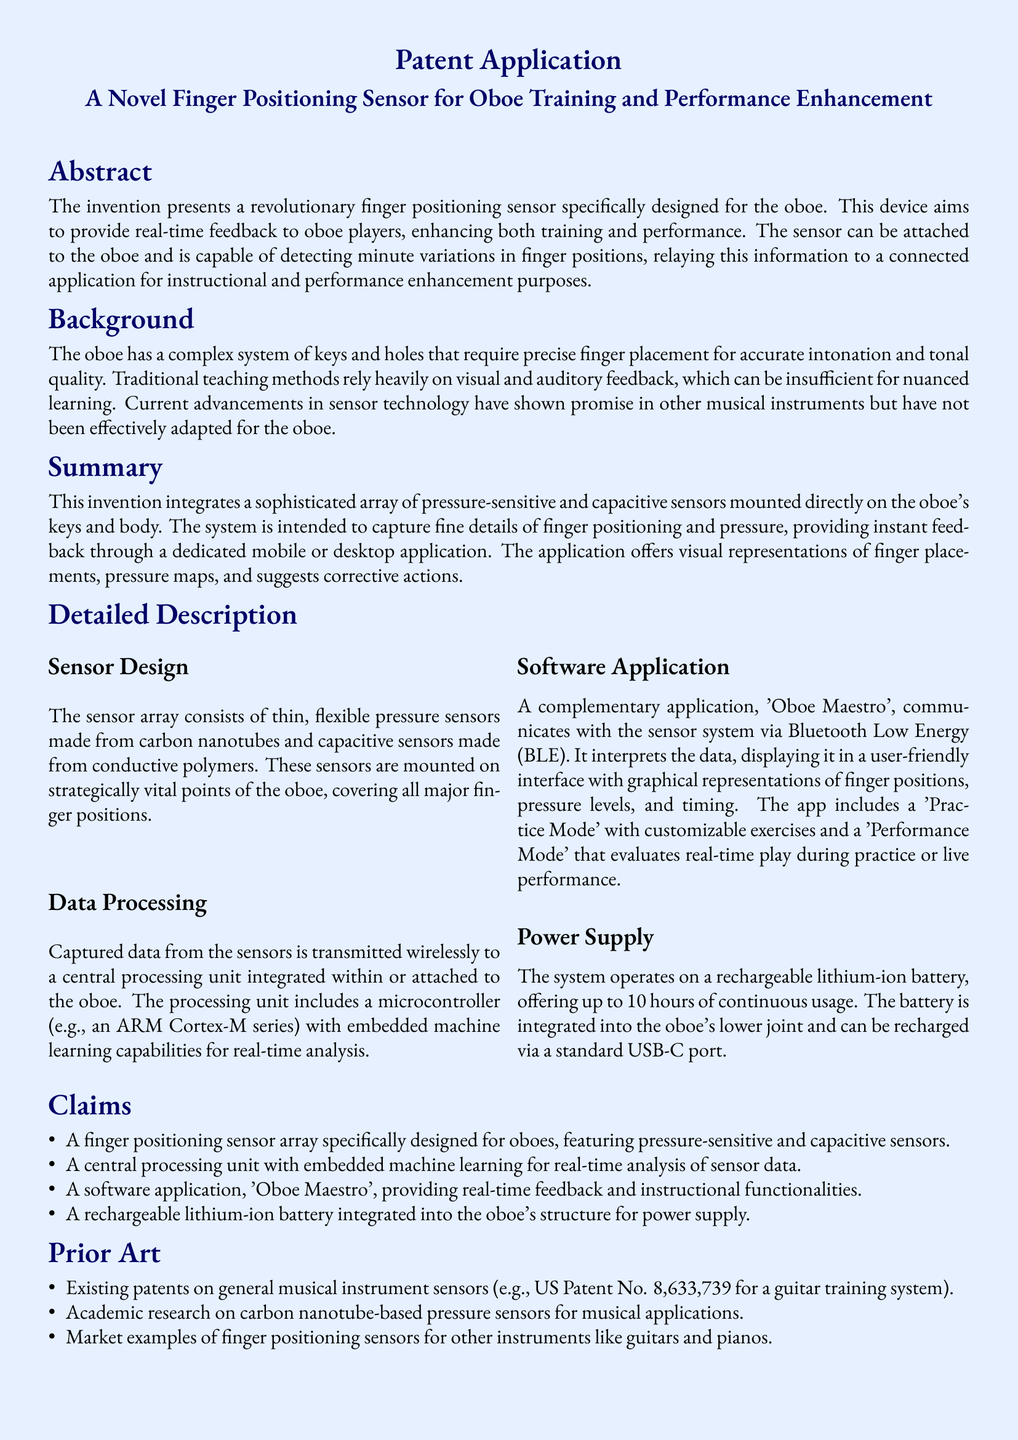What is the name of the novel sensor? The document specifies the invention as "A Novel Finger Positioning Sensor for Oboe Training and Performance Enhancement."
Answer: A Novel Finger Positioning Sensor for Oboe Training and Performance Enhancement What type of sensors does the device use? The document mentions "pressure-sensitive and capacitive sensors" as the types used in the device.
Answer: Pressure-sensitive and capacitive sensors What is the name of the complementary application? The software application that accompanies the sensor system is referred to as 'Oboe Maestro' in the document.
Answer: Oboe Maestro How long does the battery last? The document states that the system operates on a rechargeable lithium-ion battery offering "up to 10 hours" of continuous usage.
Answer: 10 hours What is the purpose of the 'Practice Mode'? The 'Practice Mode' offers "customizable exercises" for users according to the document.
Answer: Customizable exercises In which joint is the battery integrated? The battery is stated to be integrated into "the oboe's lower joint" in the document.
Answer: The oboe's lower joint What technology is used for wireless data transmission? The document indicates that the system communicates wirelessly using "Bluetooth Low Energy (BLE)."
Answer: Bluetooth Low Energy (BLE) What is the primary benefit for beginner oboists? The document mentions that the device helps in "enhancing the learning curve" for beginner oboists.
Answer: Enhancing the learning curve What type of feedback does the sensor provide? The sensor is designed to provide "real-time feedback" to oboe players according to the document.
Answer: Real-time feedback 